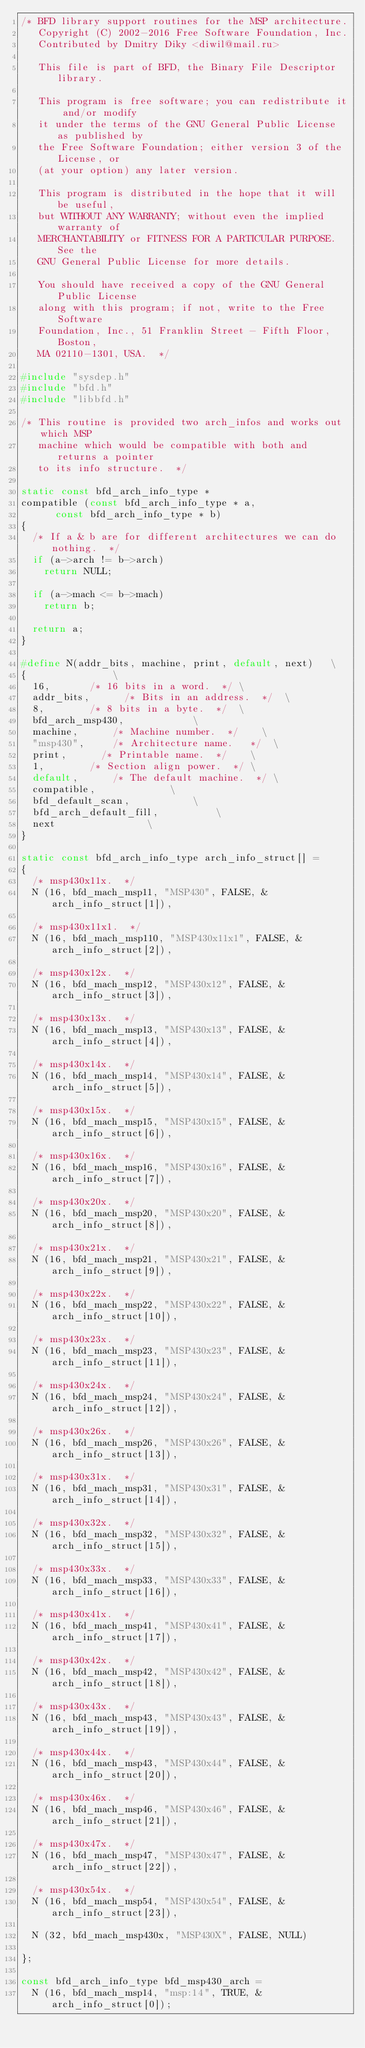Convert code to text. <code><loc_0><loc_0><loc_500><loc_500><_C_>/* BFD library support routines for the MSP architecture.
   Copyright (C) 2002-2016 Free Software Foundation, Inc.
   Contributed by Dmitry Diky <diwil@mail.ru>

   This file is part of BFD, the Binary File Descriptor library.

   This program is free software; you can redistribute it and/or modify
   it under the terms of the GNU General Public License as published by
   the Free Software Foundation; either version 3 of the License, or
   (at your option) any later version.

   This program is distributed in the hope that it will be useful,
   but WITHOUT ANY WARRANTY; without even the implied warranty of
   MERCHANTABILITY or FITNESS FOR A PARTICULAR PURPOSE.  See the
   GNU General Public License for more details.

   You should have received a copy of the GNU General Public License
   along with this program; if not, write to the Free Software
   Foundation, Inc., 51 Franklin Street - Fifth Floor, Boston,
   MA 02110-1301, USA.  */

#include "sysdep.h"
#include "bfd.h"
#include "libbfd.h"

/* This routine is provided two arch_infos and works out which MSP
   machine which would be compatible with both and returns a pointer
   to its info structure.  */

static const bfd_arch_info_type *
compatible (const bfd_arch_info_type * a,
	    const bfd_arch_info_type * b)
{
  /* If a & b are for different architectures we can do nothing.  */
  if (a->arch != b->arch)
    return NULL;

  if (a->mach <= b->mach)
    return b;

  return a;
}

#define N(addr_bits, machine, print, default, next)		\
{								\
  16,				/* 16 bits in a word.  */	\
  addr_bits,			/* Bits in an address.  */	\
  8,				/* 8 bits in a byte.  */	\
  bfd_arch_msp430,						\
  machine,			/* Machine number.  */		\
  "msp430",			/* Architecture name.   */	\
  print,			/* Printable name.  */		\
  1,				/* Section align power.  */	\
  default,			/* The default machine.  */	\
  compatible,							\
  bfd_default_scan,						\
  bfd_arch_default_fill,					\
  next								\
}

static const bfd_arch_info_type arch_info_struct[] =
{
  /* msp430x11x.  */
  N (16, bfd_mach_msp11, "MSP430", FALSE, & arch_info_struct[1]),

  /* msp430x11x1.  */
  N (16, bfd_mach_msp110, "MSP430x11x1", FALSE, & arch_info_struct[2]),

  /* msp430x12x.  */
  N (16, bfd_mach_msp12, "MSP430x12", FALSE, & arch_info_struct[3]),

  /* msp430x13x.  */
  N (16, bfd_mach_msp13, "MSP430x13", FALSE, & arch_info_struct[4]),

  /* msp430x14x.  */
  N (16, bfd_mach_msp14, "MSP430x14", FALSE, & arch_info_struct[5]),

  /* msp430x15x.  */
  N (16, bfd_mach_msp15, "MSP430x15", FALSE, & arch_info_struct[6]),

  /* msp430x16x.  */
  N (16, bfd_mach_msp16, "MSP430x16", FALSE, & arch_info_struct[7]),

  /* msp430x20x.  */
  N (16, bfd_mach_msp20, "MSP430x20", FALSE, & arch_info_struct[8]),

  /* msp430x21x.  */
  N (16, bfd_mach_msp21, "MSP430x21", FALSE, & arch_info_struct[9]),

  /* msp430x22x.  */
  N (16, bfd_mach_msp22, "MSP430x22", FALSE, & arch_info_struct[10]),

  /* msp430x23x.  */
  N (16, bfd_mach_msp23, "MSP430x23", FALSE, & arch_info_struct[11]),

  /* msp430x24x.  */
  N (16, bfd_mach_msp24, "MSP430x24", FALSE, & arch_info_struct[12]),

  /* msp430x26x.  */
  N (16, bfd_mach_msp26, "MSP430x26", FALSE, & arch_info_struct[13]),

  /* msp430x31x.  */
  N (16, bfd_mach_msp31, "MSP430x31", FALSE, & arch_info_struct[14]),

  /* msp430x32x.  */
  N (16, bfd_mach_msp32, "MSP430x32", FALSE, & arch_info_struct[15]),

  /* msp430x33x.  */
  N (16, bfd_mach_msp33, "MSP430x33", FALSE, & arch_info_struct[16]),

  /* msp430x41x.  */
  N (16, bfd_mach_msp41, "MSP430x41", FALSE, & arch_info_struct[17]),

  /* msp430x42x.  */
  N (16, bfd_mach_msp42, "MSP430x42", FALSE, & arch_info_struct[18]),

  /* msp430x43x.  */
  N (16, bfd_mach_msp43, "MSP430x43", FALSE, & arch_info_struct[19]),

  /* msp430x44x.  */
  N (16, bfd_mach_msp43, "MSP430x44", FALSE, & arch_info_struct[20]),

  /* msp430x46x.  */
  N (16, bfd_mach_msp46, "MSP430x46", FALSE, & arch_info_struct[21]),

  /* msp430x47x.  */
  N (16, bfd_mach_msp47, "MSP430x47", FALSE, & arch_info_struct[22]),

  /* msp430x54x.  */
  N (16, bfd_mach_msp54, "MSP430x54", FALSE, & arch_info_struct[23]),

  N (32, bfd_mach_msp430x, "MSP430X", FALSE, NULL)

};

const bfd_arch_info_type bfd_msp430_arch =
  N (16, bfd_mach_msp14, "msp:14", TRUE, & arch_info_struct[0]);

</code> 